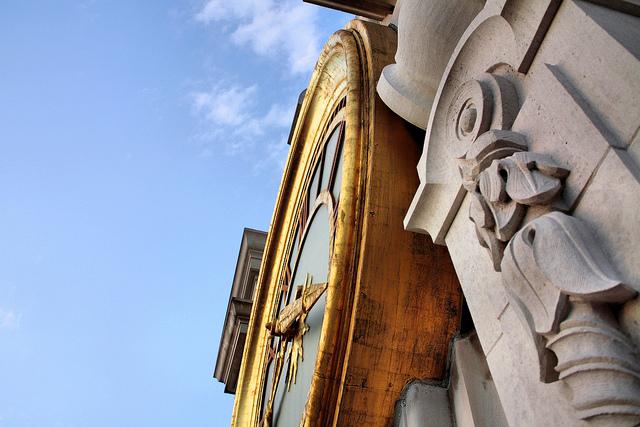What is the sky made of?
Keep it brief. Air. Could the clock be outdoors?
Keep it brief. Yes. What color is the sky?
Give a very brief answer. Blue. 